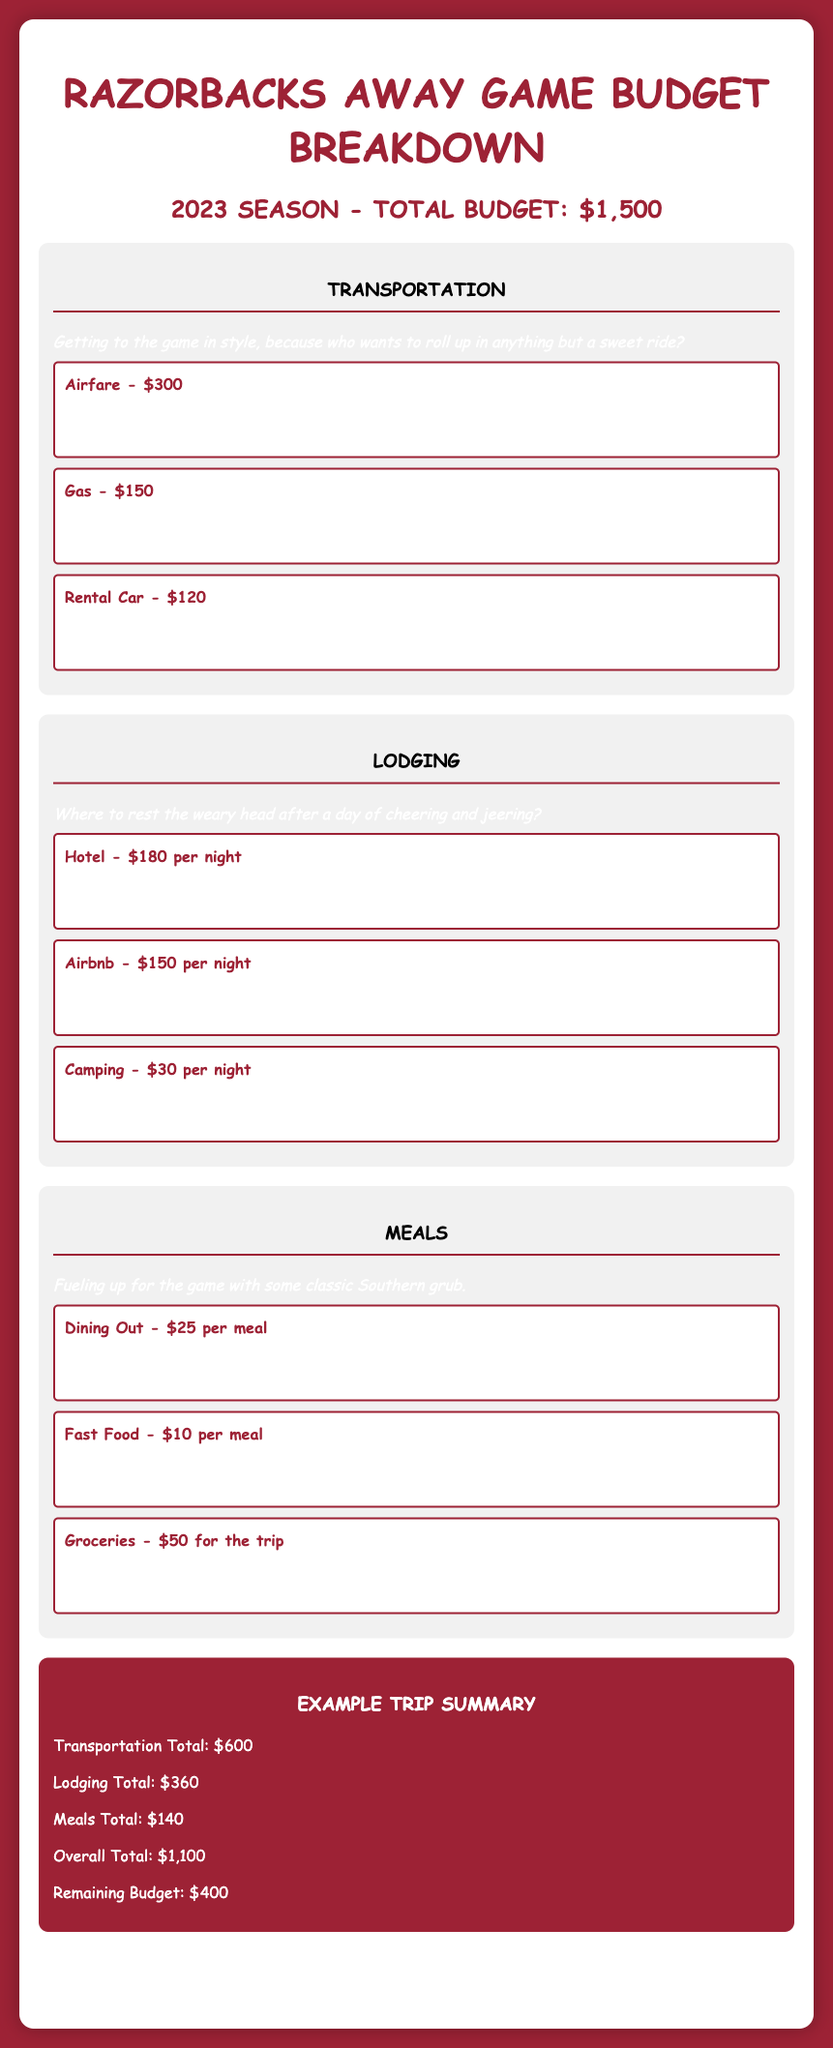What is the total budget for the 2023 season? The total budget is stated explicitly in the document as $1,500.
Answer: $1,500 How much is the airfare for the trip? The airfare is detailed under transportation as $300 for a round trip from Little Rock to Dallas.
Answer: $300 What is the lodging option with the highest cost per night? The hotel option at $180 per night is the highest lodging cost mentioned in the document.
Answer: $180 per night What is the total cost for transportation? The document sums the transportation expenses which totals $600.
Answer: $600 How much is allocated for meals for the trip? The total meals expense provided in the document is $140.
Answer: $140 Which lodging option is the cheapest per night? The camping option is provided as $30 per night, making it the cheapest lodging choice.
Answer: $30 per night What is the remaining budget after accounting for expenses? The remaining budget, calculated in the summary, is $400.
Answer: $400 How much does it cost to dine out per meal? Dining out is listed at $25 per meal in the meals section of the document.
Answer: $25 per meal What is the total lodging cost for the trip? The lodging expenses add up to a total of $360 as outlined in the summary section.
Answer: $360 